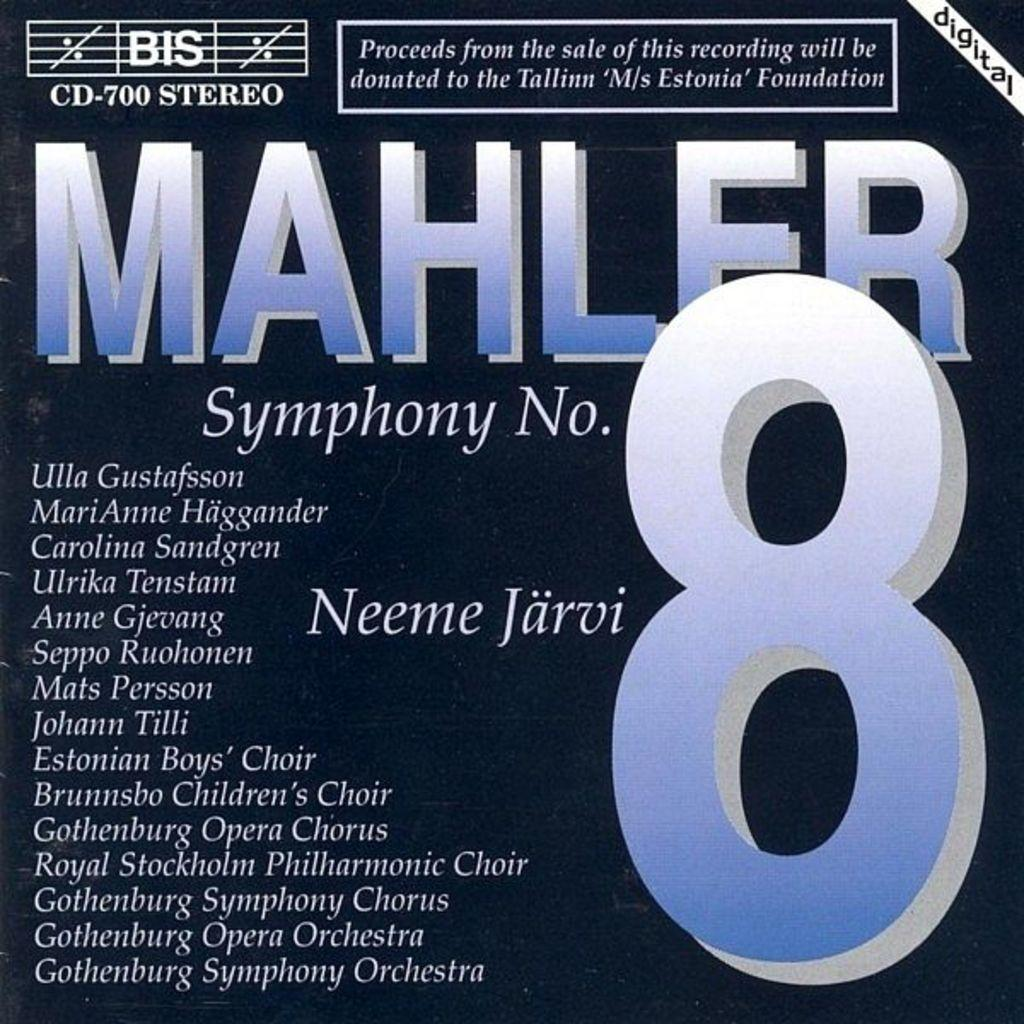Provide a one-sentence caption for the provided image. Proceeds from the sale of this Mahler 8 recording are being given to a foundation. 